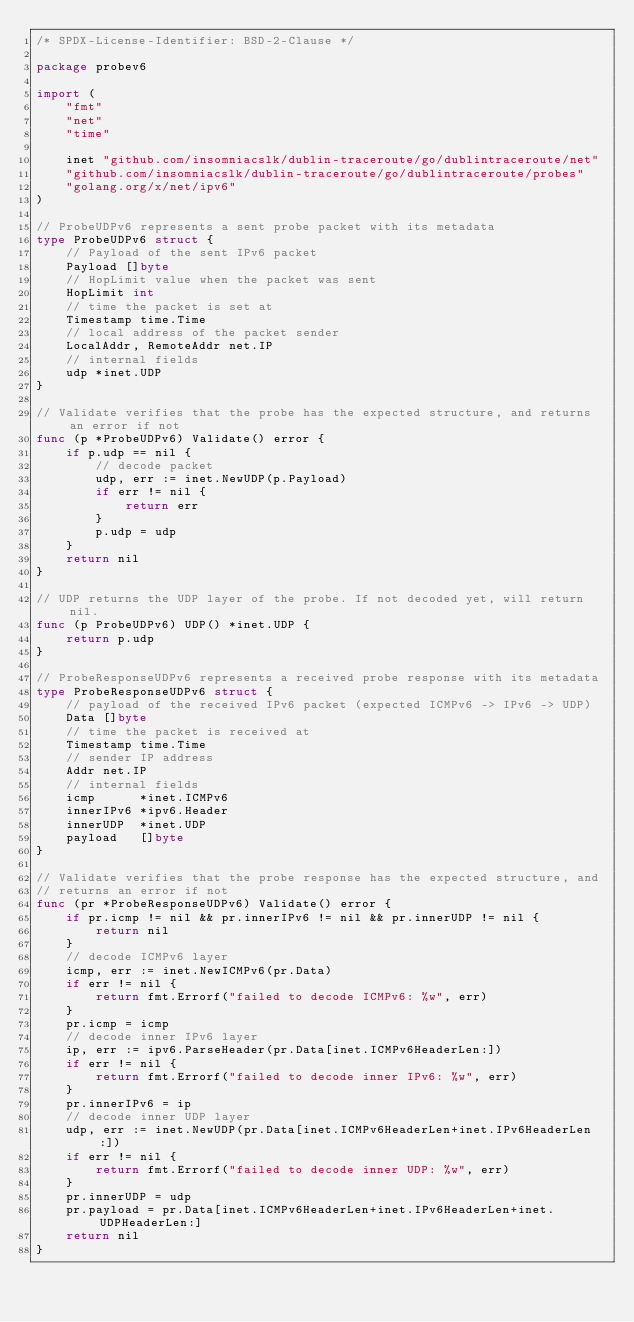Convert code to text. <code><loc_0><loc_0><loc_500><loc_500><_Go_>/* SPDX-License-Identifier: BSD-2-Clause */

package probev6

import (
	"fmt"
	"net"
	"time"

	inet "github.com/insomniacslk/dublin-traceroute/go/dublintraceroute/net"
	"github.com/insomniacslk/dublin-traceroute/go/dublintraceroute/probes"
	"golang.org/x/net/ipv6"
)

// ProbeUDPv6 represents a sent probe packet with its metadata
type ProbeUDPv6 struct {
	// Payload of the sent IPv6 packet
	Payload []byte
	// HopLimit value when the packet was sent
	HopLimit int
	// time the packet is set at
	Timestamp time.Time
	// local address of the packet sender
	LocalAddr, RemoteAddr net.IP
	// internal fields
	udp *inet.UDP
}

// Validate verifies that the probe has the expected structure, and returns an error if not
func (p *ProbeUDPv6) Validate() error {
	if p.udp == nil {
		// decode packet
		udp, err := inet.NewUDP(p.Payload)
		if err != nil {
			return err
		}
		p.udp = udp
	}
	return nil
}

// UDP returns the UDP layer of the probe. If not decoded yet, will return nil.
func (p ProbeUDPv6) UDP() *inet.UDP {
	return p.udp
}

// ProbeResponseUDPv6 represents a received probe response with its metadata
type ProbeResponseUDPv6 struct {
	// payload of the received IPv6 packet (expected ICMPv6 -> IPv6 -> UDP)
	Data []byte
	// time the packet is received at
	Timestamp time.Time
	// sender IP address
	Addr net.IP
	// internal fields
	icmp      *inet.ICMPv6
	innerIPv6 *ipv6.Header
	innerUDP  *inet.UDP
	payload   []byte
}

// Validate verifies that the probe response has the expected structure, and
// returns an error if not
func (pr *ProbeResponseUDPv6) Validate() error {
	if pr.icmp != nil && pr.innerIPv6 != nil && pr.innerUDP != nil {
		return nil
	}
	// decode ICMPv6 layer
	icmp, err := inet.NewICMPv6(pr.Data)
	if err != nil {
		return fmt.Errorf("failed to decode ICMPv6: %w", err)
	}
	pr.icmp = icmp
	// decode inner IPv6 layer
	ip, err := ipv6.ParseHeader(pr.Data[inet.ICMPv6HeaderLen:])
	if err != nil {
		return fmt.Errorf("failed to decode inner IPv6: %w", err)
	}
	pr.innerIPv6 = ip
	// decode inner UDP layer
	udp, err := inet.NewUDP(pr.Data[inet.ICMPv6HeaderLen+inet.IPv6HeaderLen:])
	if err != nil {
		return fmt.Errorf("failed to decode inner UDP: %w", err)
	}
	pr.innerUDP = udp
	pr.payload = pr.Data[inet.ICMPv6HeaderLen+inet.IPv6HeaderLen+inet.UDPHeaderLen:]
	return nil
}
</code> 